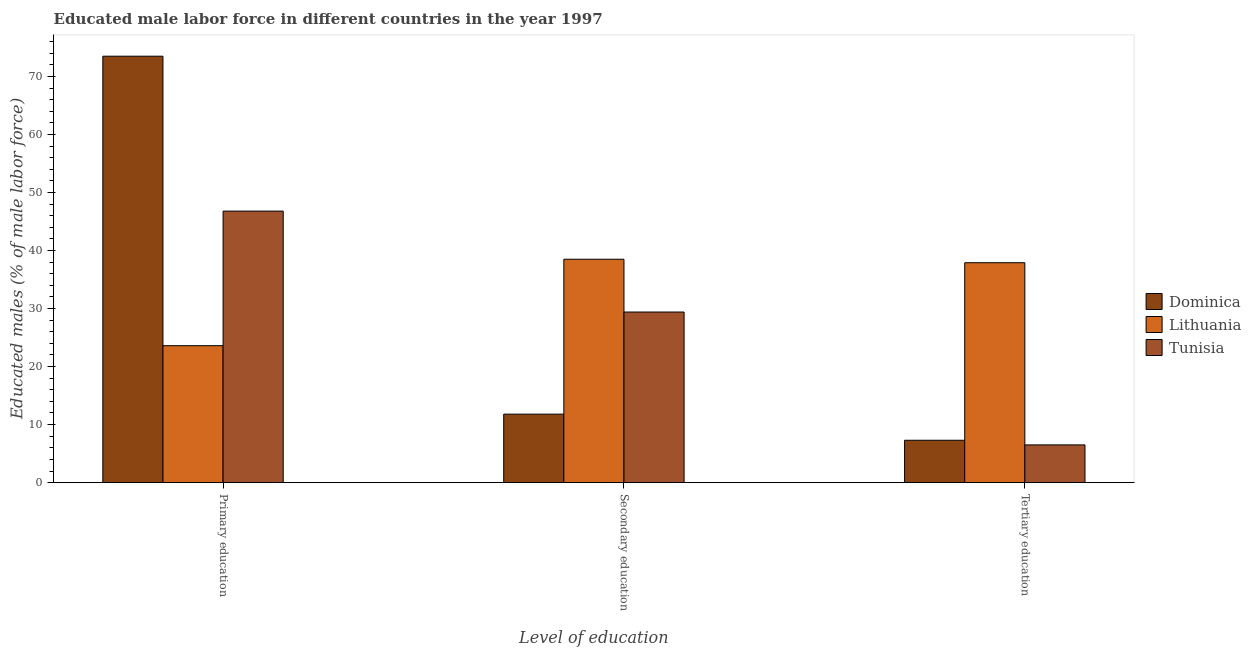How many different coloured bars are there?
Offer a very short reply. 3. Are the number of bars per tick equal to the number of legend labels?
Offer a very short reply. Yes. Are the number of bars on each tick of the X-axis equal?
Provide a succinct answer. Yes. How many bars are there on the 2nd tick from the left?
Keep it short and to the point. 3. How many bars are there on the 3rd tick from the right?
Offer a terse response. 3. What is the label of the 2nd group of bars from the left?
Offer a very short reply. Secondary education. What is the percentage of male labor force who received primary education in Tunisia?
Offer a terse response. 46.8. Across all countries, what is the maximum percentage of male labor force who received secondary education?
Your answer should be very brief. 38.5. Across all countries, what is the minimum percentage of male labor force who received primary education?
Ensure brevity in your answer.  23.6. In which country was the percentage of male labor force who received secondary education maximum?
Provide a succinct answer. Lithuania. In which country was the percentage of male labor force who received tertiary education minimum?
Give a very brief answer. Tunisia. What is the total percentage of male labor force who received secondary education in the graph?
Your answer should be compact. 79.7. What is the difference between the percentage of male labor force who received primary education in Lithuania and that in Tunisia?
Keep it short and to the point. -23.2. What is the difference between the percentage of male labor force who received primary education in Lithuania and the percentage of male labor force who received tertiary education in Tunisia?
Give a very brief answer. 17.1. What is the average percentage of male labor force who received tertiary education per country?
Ensure brevity in your answer.  17.23. What is the difference between the percentage of male labor force who received primary education and percentage of male labor force who received secondary education in Tunisia?
Your response must be concise. 17.4. In how many countries, is the percentage of male labor force who received secondary education greater than 6 %?
Offer a very short reply. 3. What is the ratio of the percentage of male labor force who received primary education in Tunisia to that in Lithuania?
Offer a very short reply. 1.98. Is the percentage of male labor force who received tertiary education in Dominica less than that in Tunisia?
Give a very brief answer. No. What is the difference between the highest and the second highest percentage of male labor force who received primary education?
Offer a very short reply. 26.7. What is the difference between the highest and the lowest percentage of male labor force who received secondary education?
Provide a succinct answer. 26.7. In how many countries, is the percentage of male labor force who received primary education greater than the average percentage of male labor force who received primary education taken over all countries?
Your answer should be very brief. 1. Is the sum of the percentage of male labor force who received tertiary education in Dominica and Lithuania greater than the maximum percentage of male labor force who received secondary education across all countries?
Give a very brief answer. Yes. What does the 1st bar from the left in Tertiary education represents?
Offer a terse response. Dominica. What does the 3rd bar from the right in Primary education represents?
Offer a terse response. Dominica. How many bars are there?
Ensure brevity in your answer.  9. Are all the bars in the graph horizontal?
Provide a succinct answer. No. How many countries are there in the graph?
Give a very brief answer. 3. Does the graph contain grids?
Give a very brief answer. No. What is the title of the graph?
Your response must be concise. Educated male labor force in different countries in the year 1997. Does "Burundi" appear as one of the legend labels in the graph?
Give a very brief answer. No. What is the label or title of the X-axis?
Ensure brevity in your answer.  Level of education. What is the label or title of the Y-axis?
Make the answer very short. Educated males (% of male labor force). What is the Educated males (% of male labor force) in Dominica in Primary education?
Ensure brevity in your answer.  73.5. What is the Educated males (% of male labor force) in Lithuania in Primary education?
Your answer should be compact. 23.6. What is the Educated males (% of male labor force) in Tunisia in Primary education?
Provide a short and direct response. 46.8. What is the Educated males (% of male labor force) in Dominica in Secondary education?
Give a very brief answer. 11.8. What is the Educated males (% of male labor force) in Lithuania in Secondary education?
Your answer should be very brief. 38.5. What is the Educated males (% of male labor force) of Tunisia in Secondary education?
Your response must be concise. 29.4. What is the Educated males (% of male labor force) in Dominica in Tertiary education?
Make the answer very short. 7.3. What is the Educated males (% of male labor force) in Lithuania in Tertiary education?
Keep it short and to the point. 37.9. What is the Educated males (% of male labor force) of Tunisia in Tertiary education?
Your answer should be very brief. 6.5. Across all Level of education, what is the maximum Educated males (% of male labor force) in Dominica?
Offer a terse response. 73.5. Across all Level of education, what is the maximum Educated males (% of male labor force) of Lithuania?
Provide a succinct answer. 38.5. Across all Level of education, what is the maximum Educated males (% of male labor force) in Tunisia?
Ensure brevity in your answer.  46.8. Across all Level of education, what is the minimum Educated males (% of male labor force) of Dominica?
Make the answer very short. 7.3. Across all Level of education, what is the minimum Educated males (% of male labor force) in Lithuania?
Ensure brevity in your answer.  23.6. What is the total Educated males (% of male labor force) in Dominica in the graph?
Offer a very short reply. 92.6. What is the total Educated males (% of male labor force) in Lithuania in the graph?
Provide a short and direct response. 100. What is the total Educated males (% of male labor force) of Tunisia in the graph?
Ensure brevity in your answer.  82.7. What is the difference between the Educated males (% of male labor force) of Dominica in Primary education and that in Secondary education?
Offer a terse response. 61.7. What is the difference between the Educated males (% of male labor force) in Lithuania in Primary education and that in Secondary education?
Offer a very short reply. -14.9. What is the difference between the Educated males (% of male labor force) in Tunisia in Primary education and that in Secondary education?
Make the answer very short. 17.4. What is the difference between the Educated males (% of male labor force) in Dominica in Primary education and that in Tertiary education?
Offer a terse response. 66.2. What is the difference between the Educated males (% of male labor force) of Lithuania in Primary education and that in Tertiary education?
Ensure brevity in your answer.  -14.3. What is the difference between the Educated males (% of male labor force) in Tunisia in Primary education and that in Tertiary education?
Offer a terse response. 40.3. What is the difference between the Educated males (% of male labor force) of Lithuania in Secondary education and that in Tertiary education?
Keep it short and to the point. 0.6. What is the difference between the Educated males (% of male labor force) of Tunisia in Secondary education and that in Tertiary education?
Offer a terse response. 22.9. What is the difference between the Educated males (% of male labor force) of Dominica in Primary education and the Educated males (% of male labor force) of Lithuania in Secondary education?
Provide a succinct answer. 35. What is the difference between the Educated males (% of male labor force) of Dominica in Primary education and the Educated males (% of male labor force) of Tunisia in Secondary education?
Your answer should be compact. 44.1. What is the difference between the Educated males (% of male labor force) of Dominica in Primary education and the Educated males (% of male labor force) of Lithuania in Tertiary education?
Offer a terse response. 35.6. What is the difference between the Educated males (% of male labor force) of Dominica in Primary education and the Educated males (% of male labor force) of Tunisia in Tertiary education?
Your response must be concise. 67. What is the difference between the Educated males (% of male labor force) in Dominica in Secondary education and the Educated males (% of male labor force) in Lithuania in Tertiary education?
Your response must be concise. -26.1. What is the difference between the Educated males (% of male labor force) in Lithuania in Secondary education and the Educated males (% of male labor force) in Tunisia in Tertiary education?
Your answer should be compact. 32. What is the average Educated males (% of male labor force) of Dominica per Level of education?
Offer a very short reply. 30.87. What is the average Educated males (% of male labor force) in Lithuania per Level of education?
Your answer should be compact. 33.33. What is the average Educated males (% of male labor force) in Tunisia per Level of education?
Ensure brevity in your answer.  27.57. What is the difference between the Educated males (% of male labor force) in Dominica and Educated males (% of male labor force) in Lithuania in Primary education?
Offer a very short reply. 49.9. What is the difference between the Educated males (% of male labor force) of Dominica and Educated males (% of male labor force) of Tunisia in Primary education?
Your answer should be very brief. 26.7. What is the difference between the Educated males (% of male labor force) in Lithuania and Educated males (% of male labor force) in Tunisia in Primary education?
Make the answer very short. -23.2. What is the difference between the Educated males (% of male labor force) of Dominica and Educated males (% of male labor force) of Lithuania in Secondary education?
Offer a very short reply. -26.7. What is the difference between the Educated males (% of male labor force) of Dominica and Educated males (% of male labor force) of Tunisia in Secondary education?
Offer a very short reply. -17.6. What is the difference between the Educated males (% of male labor force) of Dominica and Educated males (% of male labor force) of Lithuania in Tertiary education?
Your answer should be compact. -30.6. What is the difference between the Educated males (% of male labor force) in Dominica and Educated males (% of male labor force) in Tunisia in Tertiary education?
Ensure brevity in your answer.  0.8. What is the difference between the Educated males (% of male labor force) of Lithuania and Educated males (% of male labor force) of Tunisia in Tertiary education?
Your answer should be very brief. 31.4. What is the ratio of the Educated males (% of male labor force) in Dominica in Primary education to that in Secondary education?
Provide a succinct answer. 6.23. What is the ratio of the Educated males (% of male labor force) of Lithuania in Primary education to that in Secondary education?
Your answer should be compact. 0.61. What is the ratio of the Educated males (% of male labor force) of Tunisia in Primary education to that in Secondary education?
Offer a terse response. 1.59. What is the ratio of the Educated males (% of male labor force) in Dominica in Primary education to that in Tertiary education?
Make the answer very short. 10.07. What is the ratio of the Educated males (% of male labor force) in Lithuania in Primary education to that in Tertiary education?
Keep it short and to the point. 0.62. What is the ratio of the Educated males (% of male labor force) in Dominica in Secondary education to that in Tertiary education?
Make the answer very short. 1.62. What is the ratio of the Educated males (% of male labor force) of Lithuania in Secondary education to that in Tertiary education?
Your answer should be very brief. 1.02. What is the ratio of the Educated males (% of male labor force) of Tunisia in Secondary education to that in Tertiary education?
Offer a terse response. 4.52. What is the difference between the highest and the second highest Educated males (% of male labor force) in Dominica?
Your answer should be compact. 61.7. What is the difference between the highest and the second highest Educated males (% of male labor force) of Lithuania?
Offer a terse response. 0.6. What is the difference between the highest and the lowest Educated males (% of male labor force) of Dominica?
Your answer should be compact. 66.2. What is the difference between the highest and the lowest Educated males (% of male labor force) of Tunisia?
Give a very brief answer. 40.3. 